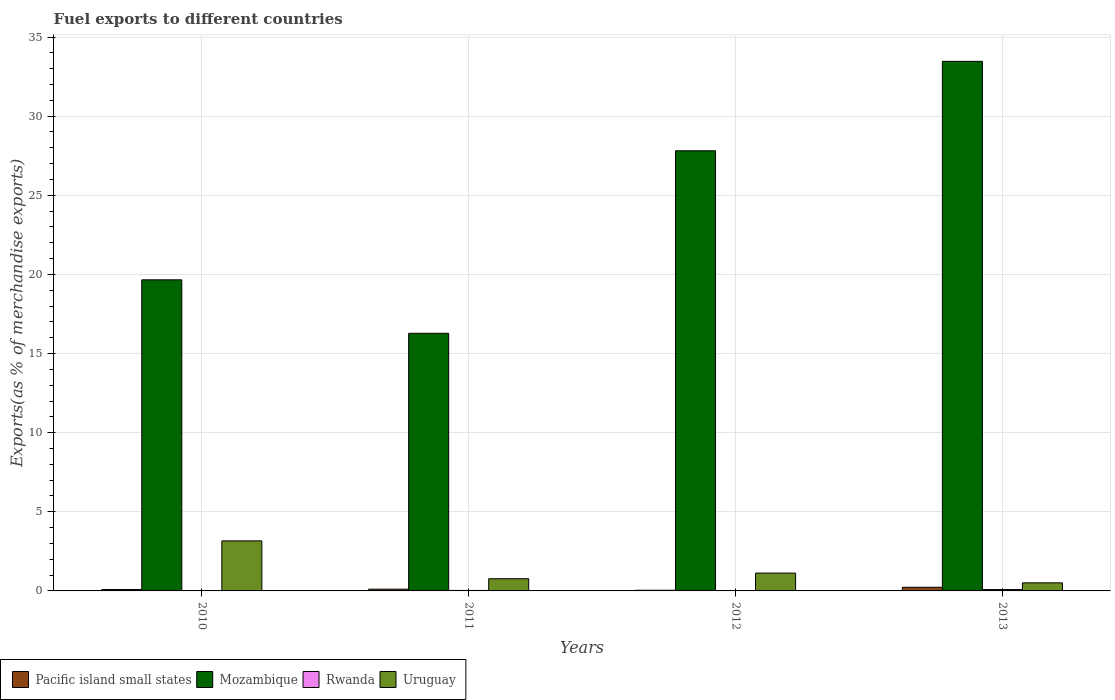Are the number of bars on each tick of the X-axis equal?
Provide a succinct answer. Yes. How many bars are there on the 4th tick from the left?
Give a very brief answer. 4. In how many cases, is the number of bars for a given year not equal to the number of legend labels?
Ensure brevity in your answer.  0. What is the percentage of exports to different countries in Rwanda in 2012?
Offer a terse response. 0.02. Across all years, what is the maximum percentage of exports to different countries in Rwanda?
Make the answer very short. 0.08. Across all years, what is the minimum percentage of exports to different countries in Uruguay?
Your answer should be very brief. 0.51. What is the total percentage of exports to different countries in Pacific island small states in the graph?
Offer a terse response. 0.47. What is the difference between the percentage of exports to different countries in Mozambique in 2011 and that in 2012?
Ensure brevity in your answer.  -11.53. What is the difference between the percentage of exports to different countries in Uruguay in 2010 and the percentage of exports to different countries in Rwanda in 2012?
Offer a very short reply. 3.14. What is the average percentage of exports to different countries in Uruguay per year?
Offer a terse response. 1.39. In the year 2012, what is the difference between the percentage of exports to different countries in Rwanda and percentage of exports to different countries in Pacific island small states?
Keep it short and to the point. -0.02. In how many years, is the percentage of exports to different countries in Mozambique greater than 17 %?
Keep it short and to the point. 3. What is the ratio of the percentage of exports to different countries in Pacific island small states in 2010 to that in 2013?
Provide a short and direct response. 0.39. What is the difference between the highest and the second highest percentage of exports to different countries in Uruguay?
Make the answer very short. 2.03. What is the difference between the highest and the lowest percentage of exports to different countries in Rwanda?
Provide a short and direct response. 0.08. In how many years, is the percentage of exports to different countries in Pacific island small states greater than the average percentage of exports to different countries in Pacific island small states taken over all years?
Offer a terse response. 1. Is the sum of the percentage of exports to different countries in Uruguay in 2010 and 2013 greater than the maximum percentage of exports to different countries in Rwanda across all years?
Offer a terse response. Yes. Is it the case that in every year, the sum of the percentage of exports to different countries in Rwanda and percentage of exports to different countries in Uruguay is greater than the sum of percentage of exports to different countries in Mozambique and percentage of exports to different countries in Pacific island small states?
Give a very brief answer. Yes. What does the 4th bar from the left in 2012 represents?
Offer a terse response. Uruguay. What does the 1st bar from the right in 2010 represents?
Your answer should be compact. Uruguay. Is it the case that in every year, the sum of the percentage of exports to different countries in Mozambique and percentage of exports to different countries in Pacific island small states is greater than the percentage of exports to different countries in Rwanda?
Ensure brevity in your answer.  Yes. How many years are there in the graph?
Your answer should be very brief. 4. What is the difference between two consecutive major ticks on the Y-axis?
Offer a very short reply. 5. Are the values on the major ticks of Y-axis written in scientific E-notation?
Provide a succinct answer. No. Does the graph contain grids?
Your answer should be very brief. Yes. What is the title of the graph?
Offer a very short reply. Fuel exports to different countries. What is the label or title of the Y-axis?
Provide a short and direct response. Exports(as % of merchandise exports). What is the Exports(as % of merchandise exports) in Pacific island small states in 2010?
Your answer should be very brief. 0.09. What is the Exports(as % of merchandise exports) of Mozambique in 2010?
Your answer should be compact. 19.66. What is the Exports(as % of merchandise exports) of Rwanda in 2010?
Offer a terse response. 0.01. What is the Exports(as % of merchandise exports) of Uruguay in 2010?
Ensure brevity in your answer.  3.16. What is the Exports(as % of merchandise exports) of Pacific island small states in 2011?
Your answer should be very brief. 0.11. What is the Exports(as % of merchandise exports) in Mozambique in 2011?
Your answer should be very brief. 16.28. What is the Exports(as % of merchandise exports) in Rwanda in 2011?
Ensure brevity in your answer.  0.03. What is the Exports(as % of merchandise exports) in Uruguay in 2011?
Provide a succinct answer. 0.77. What is the Exports(as % of merchandise exports) of Pacific island small states in 2012?
Keep it short and to the point. 0.04. What is the Exports(as % of merchandise exports) of Mozambique in 2012?
Make the answer very short. 27.81. What is the Exports(as % of merchandise exports) in Rwanda in 2012?
Offer a very short reply. 0.02. What is the Exports(as % of merchandise exports) in Uruguay in 2012?
Your answer should be compact. 1.13. What is the Exports(as % of merchandise exports) in Pacific island small states in 2013?
Your answer should be very brief. 0.23. What is the Exports(as % of merchandise exports) of Mozambique in 2013?
Ensure brevity in your answer.  33.46. What is the Exports(as % of merchandise exports) of Rwanda in 2013?
Provide a short and direct response. 0.08. What is the Exports(as % of merchandise exports) in Uruguay in 2013?
Ensure brevity in your answer.  0.51. Across all years, what is the maximum Exports(as % of merchandise exports) of Pacific island small states?
Offer a very short reply. 0.23. Across all years, what is the maximum Exports(as % of merchandise exports) of Mozambique?
Give a very brief answer. 33.46. Across all years, what is the maximum Exports(as % of merchandise exports) of Rwanda?
Your answer should be compact. 0.08. Across all years, what is the maximum Exports(as % of merchandise exports) in Uruguay?
Your answer should be compact. 3.16. Across all years, what is the minimum Exports(as % of merchandise exports) in Pacific island small states?
Your response must be concise. 0.04. Across all years, what is the minimum Exports(as % of merchandise exports) of Mozambique?
Offer a terse response. 16.28. Across all years, what is the minimum Exports(as % of merchandise exports) of Rwanda?
Your response must be concise. 0.01. Across all years, what is the minimum Exports(as % of merchandise exports) of Uruguay?
Your response must be concise. 0.51. What is the total Exports(as % of merchandise exports) of Pacific island small states in the graph?
Offer a very short reply. 0.47. What is the total Exports(as % of merchandise exports) in Mozambique in the graph?
Provide a succinct answer. 97.21. What is the total Exports(as % of merchandise exports) of Rwanda in the graph?
Ensure brevity in your answer.  0.14. What is the total Exports(as % of merchandise exports) of Uruguay in the graph?
Offer a terse response. 5.57. What is the difference between the Exports(as % of merchandise exports) in Pacific island small states in 2010 and that in 2011?
Offer a very short reply. -0.02. What is the difference between the Exports(as % of merchandise exports) in Mozambique in 2010 and that in 2011?
Ensure brevity in your answer.  3.38. What is the difference between the Exports(as % of merchandise exports) in Rwanda in 2010 and that in 2011?
Provide a succinct answer. -0.03. What is the difference between the Exports(as % of merchandise exports) of Uruguay in 2010 and that in 2011?
Offer a terse response. 2.39. What is the difference between the Exports(as % of merchandise exports) in Pacific island small states in 2010 and that in 2012?
Give a very brief answer. 0.05. What is the difference between the Exports(as % of merchandise exports) of Mozambique in 2010 and that in 2012?
Provide a succinct answer. -8.15. What is the difference between the Exports(as % of merchandise exports) in Rwanda in 2010 and that in 2012?
Make the answer very short. -0.02. What is the difference between the Exports(as % of merchandise exports) of Uruguay in 2010 and that in 2012?
Offer a terse response. 2.03. What is the difference between the Exports(as % of merchandise exports) of Pacific island small states in 2010 and that in 2013?
Your answer should be compact. -0.14. What is the difference between the Exports(as % of merchandise exports) in Mozambique in 2010 and that in 2013?
Keep it short and to the point. -13.8. What is the difference between the Exports(as % of merchandise exports) of Rwanda in 2010 and that in 2013?
Keep it short and to the point. -0.08. What is the difference between the Exports(as % of merchandise exports) in Uruguay in 2010 and that in 2013?
Offer a terse response. 2.65. What is the difference between the Exports(as % of merchandise exports) in Pacific island small states in 2011 and that in 2012?
Your answer should be compact. 0.07. What is the difference between the Exports(as % of merchandise exports) of Mozambique in 2011 and that in 2012?
Offer a terse response. -11.53. What is the difference between the Exports(as % of merchandise exports) in Rwanda in 2011 and that in 2012?
Offer a terse response. 0.01. What is the difference between the Exports(as % of merchandise exports) in Uruguay in 2011 and that in 2012?
Your answer should be compact. -0.36. What is the difference between the Exports(as % of merchandise exports) in Pacific island small states in 2011 and that in 2013?
Keep it short and to the point. -0.12. What is the difference between the Exports(as % of merchandise exports) in Mozambique in 2011 and that in 2013?
Provide a short and direct response. -17.18. What is the difference between the Exports(as % of merchandise exports) in Rwanda in 2011 and that in 2013?
Give a very brief answer. -0.05. What is the difference between the Exports(as % of merchandise exports) in Uruguay in 2011 and that in 2013?
Provide a short and direct response. 0.26. What is the difference between the Exports(as % of merchandise exports) in Pacific island small states in 2012 and that in 2013?
Offer a terse response. -0.19. What is the difference between the Exports(as % of merchandise exports) in Mozambique in 2012 and that in 2013?
Make the answer very short. -5.65. What is the difference between the Exports(as % of merchandise exports) in Rwanda in 2012 and that in 2013?
Provide a short and direct response. -0.06. What is the difference between the Exports(as % of merchandise exports) in Uruguay in 2012 and that in 2013?
Ensure brevity in your answer.  0.62. What is the difference between the Exports(as % of merchandise exports) in Pacific island small states in 2010 and the Exports(as % of merchandise exports) in Mozambique in 2011?
Offer a terse response. -16.19. What is the difference between the Exports(as % of merchandise exports) in Pacific island small states in 2010 and the Exports(as % of merchandise exports) in Rwanda in 2011?
Your answer should be very brief. 0.06. What is the difference between the Exports(as % of merchandise exports) of Pacific island small states in 2010 and the Exports(as % of merchandise exports) of Uruguay in 2011?
Provide a succinct answer. -0.68. What is the difference between the Exports(as % of merchandise exports) of Mozambique in 2010 and the Exports(as % of merchandise exports) of Rwanda in 2011?
Offer a very short reply. 19.63. What is the difference between the Exports(as % of merchandise exports) of Mozambique in 2010 and the Exports(as % of merchandise exports) of Uruguay in 2011?
Provide a short and direct response. 18.89. What is the difference between the Exports(as % of merchandise exports) in Rwanda in 2010 and the Exports(as % of merchandise exports) in Uruguay in 2011?
Offer a terse response. -0.77. What is the difference between the Exports(as % of merchandise exports) of Pacific island small states in 2010 and the Exports(as % of merchandise exports) of Mozambique in 2012?
Offer a very short reply. -27.72. What is the difference between the Exports(as % of merchandise exports) in Pacific island small states in 2010 and the Exports(as % of merchandise exports) in Rwanda in 2012?
Your answer should be compact. 0.07. What is the difference between the Exports(as % of merchandise exports) in Pacific island small states in 2010 and the Exports(as % of merchandise exports) in Uruguay in 2012?
Keep it short and to the point. -1.04. What is the difference between the Exports(as % of merchandise exports) in Mozambique in 2010 and the Exports(as % of merchandise exports) in Rwanda in 2012?
Your response must be concise. 19.63. What is the difference between the Exports(as % of merchandise exports) of Mozambique in 2010 and the Exports(as % of merchandise exports) of Uruguay in 2012?
Provide a short and direct response. 18.53. What is the difference between the Exports(as % of merchandise exports) of Rwanda in 2010 and the Exports(as % of merchandise exports) of Uruguay in 2012?
Make the answer very short. -1.12. What is the difference between the Exports(as % of merchandise exports) in Pacific island small states in 2010 and the Exports(as % of merchandise exports) in Mozambique in 2013?
Keep it short and to the point. -33.37. What is the difference between the Exports(as % of merchandise exports) of Pacific island small states in 2010 and the Exports(as % of merchandise exports) of Rwanda in 2013?
Your answer should be very brief. 0.01. What is the difference between the Exports(as % of merchandise exports) in Pacific island small states in 2010 and the Exports(as % of merchandise exports) in Uruguay in 2013?
Give a very brief answer. -0.42. What is the difference between the Exports(as % of merchandise exports) in Mozambique in 2010 and the Exports(as % of merchandise exports) in Rwanda in 2013?
Give a very brief answer. 19.57. What is the difference between the Exports(as % of merchandise exports) of Mozambique in 2010 and the Exports(as % of merchandise exports) of Uruguay in 2013?
Ensure brevity in your answer.  19.15. What is the difference between the Exports(as % of merchandise exports) in Rwanda in 2010 and the Exports(as % of merchandise exports) in Uruguay in 2013?
Your response must be concise. -0.51. What is the difference between the Exports(as % of merchandise exports) in Pacific island small states in 2011 and the Exports(as % of merchandise exports) in Mozambique in 2012?
Ensure brevity in your answer.  -27.7. What is the difference between the Exports(as % of merchandise exports) in Pacific island small states in 2011 and the Exports(as % of merchandise exports) in Rwanda in 2012?
Ensure brevity in your answer.  0.09. What is the difference between the Exports(as % of merchandise exports) of Pacific island small states in 2011 and the Exports(as % of merchandise exports) of Uruguay in 2012?
Make the answer very short. -1.02. What is the difference between the Exports(as % of merchandise exports) of Mozambique in 2011 and the Exports(as % of merchandise exports) of Rwanda in 2012?
Ensure brevity in your answer.  16.25. What is the difference between the Exports(as % of merchandise exports) of Mozambique in 2011 and the Exports(as % of merchandise exports) of Uruguay in 2012?
Your answer should be very brief. 15.15. What is the difference between the Exports(as % of merchandise exports) in Rwanda in 2011 and the Exports(as % of merchandise exports) in Uruguay in 2012?
Ensure brevity in your answer.  -1.1. What is the difference between the Exports(as % of merchandise exports) of Pacific island small states in 2011 and the Exports(as % of merchandise exports) of Mozambique in 2013?
Give a very brief answer. -33.35. What is the difference between the Exports(as % of merchandise exports) of Pacific island small states in 2011 and the Exports(as % of merchandise exports) of Rwanda in 2013?
Your response must be concise. 0.03. What is the difference between the Exports(as % of merchandise exports) in Pacific island small states in 2011 and the Exports(as % of merchandise exports) in Uruguay in 2013?
Keep it short and to the point. -0.4. What is the difference between the Exports(as % of merchandise exports) of Mozambique in 2011 and the Exports(as % of merchandise exports) of Rwanda in 2013?
Keep it short and to the point. 16.19. What is the difference between the Exports(as % of merchandise exports) of Mozambique in 2011 and the Exports(as % of merchandise exports) of Uruguay in 2013?
Offer a terse response. 15.77. What is the difference between the Exports(as % of merchandise exports) in Rwanda in 2011 and the Exports(as % of merchandise exports) in Uruguay in 2013?
Your answer should be compact. -0.48. What is the difference between the Exports(as % of merchandise exports) in Pacific island small states in 2012 and the Exports(as % of merchandise exports) in Mozambique in 2013?
Your response must be concise. -33.42. What is the difference between the Exports(as % of merchandise exports) of Pacific island small states in 2012 and the Exports(as % of merchandise exports) of Rwanda in 2013?
Your response must be concise. -0.04. What is the difference between the Exports(as % of merchandise exports) of Pacific island small states in 2012 and the Exports(as % of merchandise exports) of Uruguay in 2013?
Your response must be concise. -0.47. What is the difference between the Exports(as % of merchandise exports) of Mozambique in 2012 and the Exports(as % of merchandise exports) of Rwanda in 2013?
Ensure brevity in your answer.  27.73. What is the difference between the Exports(as % of merchandise exports) in Mozambique in 2012 and the Exports(as % of merchandise exports) in Uruguay in 2013?
Offer a terse response. 27.3. What is the difference between the Exports(as % of merchandise exports) in Rwanda in 2012 and the Exports(as % of merchandise exports) in Uruguay in 2013?
Make the answer very short. -0.49. What is the average Exports(as % of merchandise exports) of Pacific island small states per year?
Your response must be concise. 0.12. What is the average Exports(as % of merchandise exports) in Mozambique per year?
Provide a succinct answer. 24.3. What is the average Exports(as % of merchandise exports) in Rwanda per year?
Your answer should be compact. 0.04. What is the average Exports(as % of merchandise exports) of Uruguay per year?
Provide a short and direct response. 1.39. In the year 2010, what is the difference between the Exports(as % of merchandise exports) in Pacific island small states and Exports(as % of merchandise exports) in Mozambique?
Make the answer very short. -19.57. In the year 2010, what is the difference between the Exports(as % of merchandise exports) of Pacific island small states and Exports(as % of merchandise exports) of Rwanda?
Give a very brief answer. 0.09. In the year 2010, what is the difference between the Exports(as % of merchandise exports) in Pacific island small states and Exports(as % of merchandise exports) in Uruguay?
Provide a short and direct response. -3.07. In the year 2010, what is the difference between the Exports(as % of merchandise exports) in Mozambique and Exports(as % of merchandise exports) in Rwanda?
Ensure brevity in your answer.  19.65. In the year 2010, what is the difference between the Exports(as % of merchandise exports) of Mozambique and Exports(as % of merchandise exports) of Uruguay?
Make the answer very short. 16.5. In the year 2010, what is the difference between the Exports(as % of merchandise exports) in Rwanda and Exports(as % of merchandise exports) in Uruguay?
Make the answer very short. -3.16. In the year 2011, what is the difference between the Exports(as % of merchandise exports) in Pacific island small states and Exports(as % of merchandise exports) in Mozambique?
Provide a succinct answer. -16.17. In the year 2011, what is the difference between the Exports(as % of merchandise exports) in Pacific island small states and Exports(as % of merchandise exports) in Rwanda?
Provide a short and direct response. 0.08. In the year 2011, what is the difference between the Exports(as % of merchandise exports) in Pacific island small states and Exports(as % of merchandise exports) in Uruguay?
Give a very brief answer. -0.66. In the year 2011, what is the difference between the Exports(as % of merchandise exports) in Mozambique and Exports(as % of merchandise exports) in Rwanda?
Make the answer very short. 16.25. In the year 2011, what is the difference between the Exports(as % of merchandise exports) in Mozambique and Exports(as % of merchandise exports) in Uruguay?
Offer a very short reply. 15.51. In the year 2011, what is the difference between the Exports(as % of merchandise exports) of Rwanda and Exports(as % of merchandise exports) of Uruguay?
Offer a terse response. -0.74. In the year 2012, what is the difference between the Exports(as % of merchandise exports) of Pacific island small states and Exports(as % of merchandise exports) of Mozambique?
Offer a terse response. -27.77. In the year 2012, what is the difference between the Exports(as % of merchandise exports) of Pacific island small states and Exports(as % of merchandise exports) of Rwanda?
Your answer should be compact. 0.02. In the year 2012, what is the difference between the Exports(as % of merchandise exports) in Pacific island small states and Exports(as % of merchandise exports) in Uruguay?
Ensure brevity in your answer.  -1.08. In the year 2012, what is the difference between the Exports(as % of merchandise exports) of Mozambique and Exports(as % of merchandise exports) of Rwanda?
Your response must be concise. 27.79. In the year 2012, what is the difference between the Exports(as % of merchandise exports) of Mozambique and Exports(as % of merchandise exports) of Uruguay?
Offer a very short reply. 26.69. In the year 2012, what is the difference between the Exports(as % of merchandise exports) in Rwanda and Exports(as % of merchandise exports) in Uruguay?
Make the answer very short. -1.1. In the year 2013, what is the difference between the Exports(as % of merchandise exports) in Pacific island small states and Exports(as % of merchandise exports) in Mozambique?
Your answer should be very brief. -33.23. In the year 2013, what is the difference between the Exports(as % of merchandise exports) in Pacific island small states and Exports(as % of merchandise exports) in Rwanda?
Offer a terse response. 0.15. In the year 2013, what is the difference between the Exports(as % of merchandise exports) of Pacific island small states and Exports(as % of merchandise exports) of Uruguay?
Make the answer very short. -0.28. In the year 2013, what is the difference between the Exports(as % of merchandise exports) in Mozambique and Exports(as % of merchandise exports) in Rwanda?
Your answer should be very brief. 33.38. In the year 2013, what is the difference between the Exports(as % of merchandise exports) in Mozambique and Exports(as % of merchandise exports) in Uruguay?
Ensure brevity in your answer.  32.95. In the year 2013, what is the difference between the Exports(as % of merchandise exports) in Rwanda and Exports(as % of merchandise exports) in Uruguay?
Your answer should be very brief. -0.43. What is the ratio of the Exports(as % of merchandise exports) in Pacific island small states in 2010 to that in 2011?
Keep it short and to the point. 0.82. What is the ratio of the Exports(as % of merchandise exports) of Mozambique in 2010 to that in 2011?
Provide a short and direct response. 1.21. What is the ratio of the Exports(as % of merchandise exports) in Rwanda in 2010 to that in 2011?
Make the answer very short. 0.17. What is the ratio of the Exports(as % of merchandise exports) of Uruguay in 2010 to that in 2011?
Ensure brevity in your answer.  4.1. What is the ratio of the Exports(as % of merchandise exports) of Pacific island small states in 2010 to that in 2012?
Your answer should be very brief. 2.11. What is the ratio of the Exports(as % of merchandise exports) of Mozambique in 2010 to that in 2012?
Offer a very short reply. 0.71. What is the ratio of the Exports(as % of merchandise exports) of Rwanda in 2010 to that in 2012?
Provide a short and direct response. 0.22. What is the ratio of the Exports(as % of merchandise exports) in Uruguay in 2010 to that in 2012?
Offer a terse response. 2.81. What is the ratio of the Exports(as % of merchandise exports) of Pacific island small states in 2010 to that in 2013?
Provide a succinct answer. 0.39. What is the ratio of the Exports(as % of merchandise exports) in Mozambique in 2010 to that in 2013?
Keep it short and to the point. 0.59. What is the ratio of the Exports(as % of merchandise exports) in Rwanda in 2010 to that in 2013?
Offer a very short reply. 0.06. What is the ratio of the Exports(as % of merchandise exports) of Uruguay in 2010 to that in 2013?
Keep it short and to the point. 6.18. What is the ratio of the Exports(as % of merchandise exports) of Pacific island small states in 2011 to that in 2012?
Your answer should be very brief. 2.58. What is the ratio of the Exports(as % of merchandise exports) in Mozambique in 2011 to that in 2012?
Your response must be concise. 0.59. What is the ratio of the Exports(as % of merchandise exports) of Rwanda in 2011 to that in 2012?
Your answer should be very brief. 1.26. What is the ratio of the Exports(as % of merchandise exports) of Uruguay in 2011 to that in 2012?
Keep it short and to the point. 0.68. What is the ratio of the Exports(as % of merchandise exports) in Pacific island small states in 2011 to that in 2013?
Offer a very short reply. 0.48. What is the ratio of the Exports(as % of merchandise exports) of Mozambique in 2011 to that in 2013?
Provide a short and direct response. 0.49. What is the ratio of the Exports(as % of merchandise exports) in Rwanda in 2011 to that in 2013?
Ensure brevity in your answer.  0.36. What is the ratio of the Exports(as % of merchandise exports) in Uruguay in 2011 to that in 2013?
Your answer should be very brief. 1.51. What is the ratio of the Exports(as % of merchandise exports) of Pacific island small states in 2012 to that in 2013?
Ensure brevity in your answer.  0.19. What is the ratio of the Exports(as % of merchandise exports) of Mozambique in 2012 to that in 2013?
Make the answer very short. 0.83. What is the ratio of the Exports(as % of merchandise exports) in Rwanda in 2012 to that in 2013?
Offer a terse response. 0.28. What is the ratio of the Exports(as % of merchandise exports) in Uruguay in 2012 to that in 2013?
Make the answer very short. 2.2. What is the difference between the highest and the second highest Exports(as % of merchandise exports) of Pacific island small states?
Your answer should be very brief. 0.12. What is the difference between the highest and the second highest Exports(as % of merchandise exports) in Mozambique?
Your response must be concise. 5.65. What is the difference between the highest and the second highest Exports(as % of merchandise exports) of Rwanda?
Your answer should be very brief. 0.05. What is the difference between the highest and the second highest Exports(as % of merchandise exports) in Uruguay?
Offer a terse response. 2.03. What is the difference between the highest and the lowest Exports(as % of merchandise exports) in Pacific island small states?
Ensure brevity in your answer.  0.19. What is the difference between the highest and the lowest Exports(as % of merchandise exports) in Mozambique?
Offer a very short reply. 17.18. What is the difference between the highest and the lowest Exports(as % of merchandise exports) in Rwanda?
Make the answer very short. 0.08. What is the difference between the highest and the lowest Exports(as % of merchandise exports) of Uruguay?
Keep it short and to the point. 2.65. 